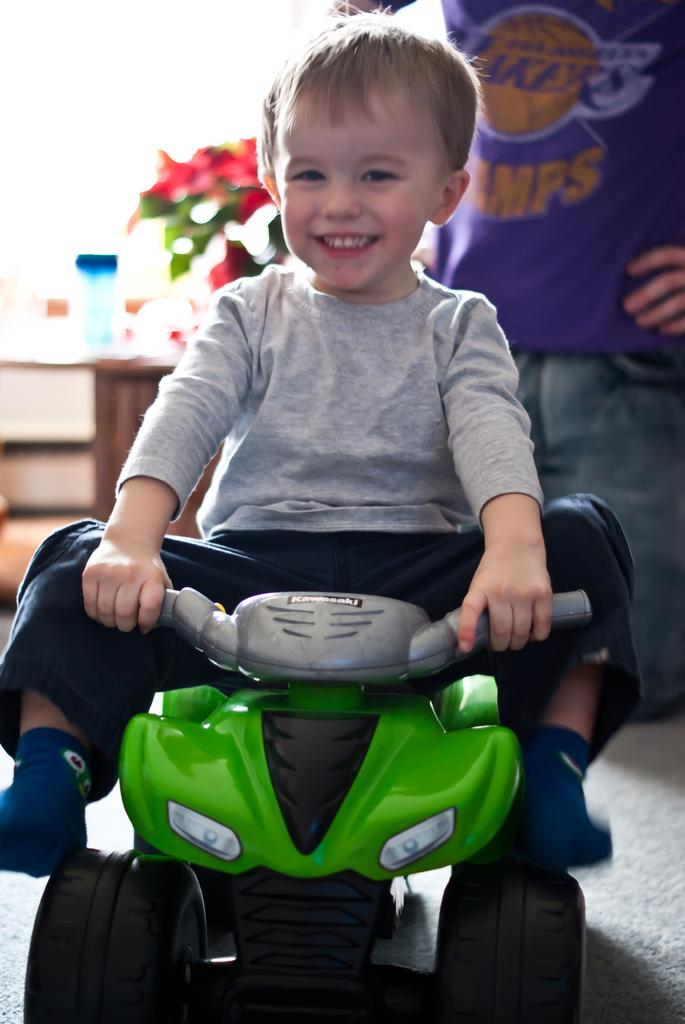What is the main subject of the image? The main subject of the image is a child. What is the child doing in the image? The child is sitting on a toy vehicle. What is the child's expression in the image? The child is smiling. What can be seen in the background of the image? There is a bottle, a plant, and a person in the background of the image. What type of linen is being used to cover the toys in the image? There is no linen visible in the image, and no toys are mentioned as being covered. 